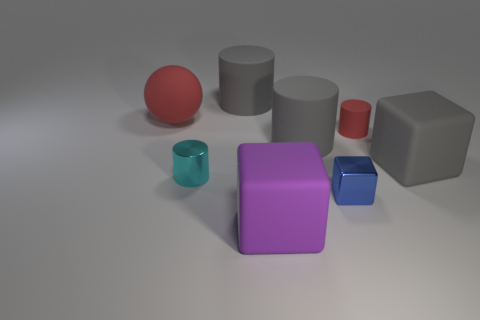Add 2 cyan cylinders. How many objects exist? 10 Subtract all cubes. How many objects are left? 5 Subtract all tiny yellow shiny cylinders. Subtract all small objects. How many objects are left? 5 Add 8 tiny matte cylinders. How many tiny matte cylinders are left? 9 Add 6 cyan things. How many cyan things exist? 7 Subtract 0 green balls. How many objects are left? 8 